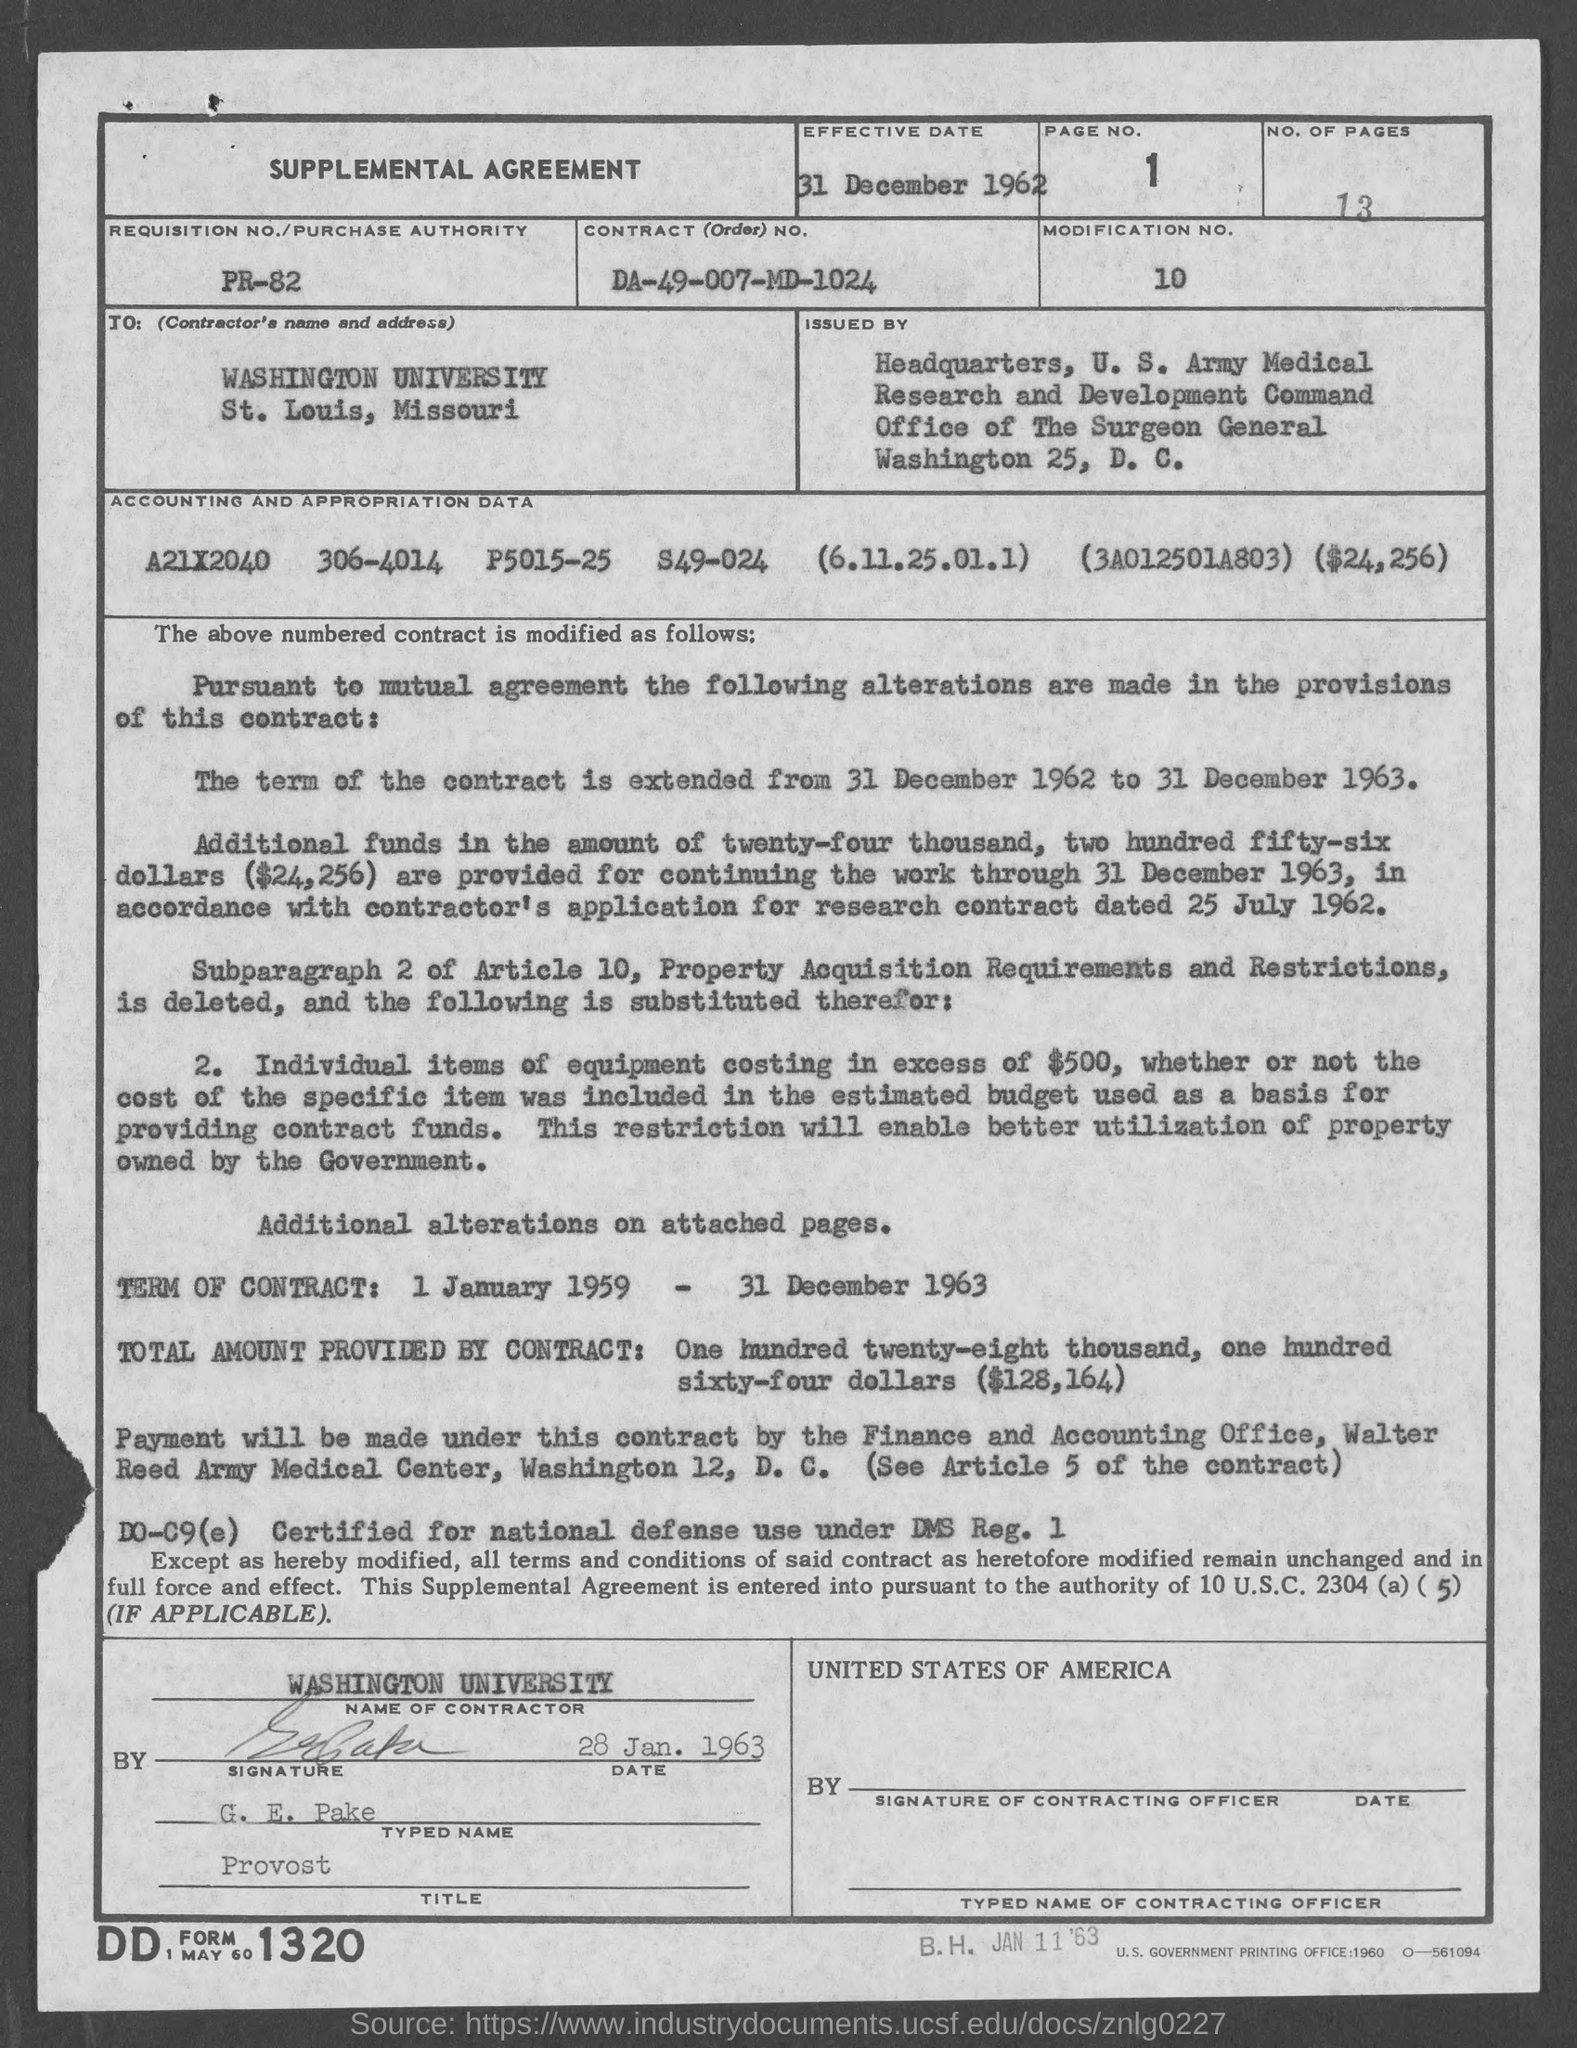What is the page number on this document?
 1 